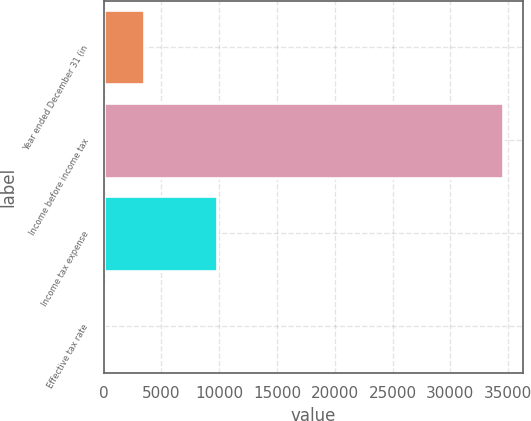<chart> <loc_0><loc_0><loc_500><loc_500><bar_chart><fcel>Year ended December 31 (in<fcel>Income before income tax<fcel>Income tax expense<fcel>Effective tax rate<nl><fcel>3479.16<fcel>34536<fcel>9803<fcel>28.4<nl></chart> 